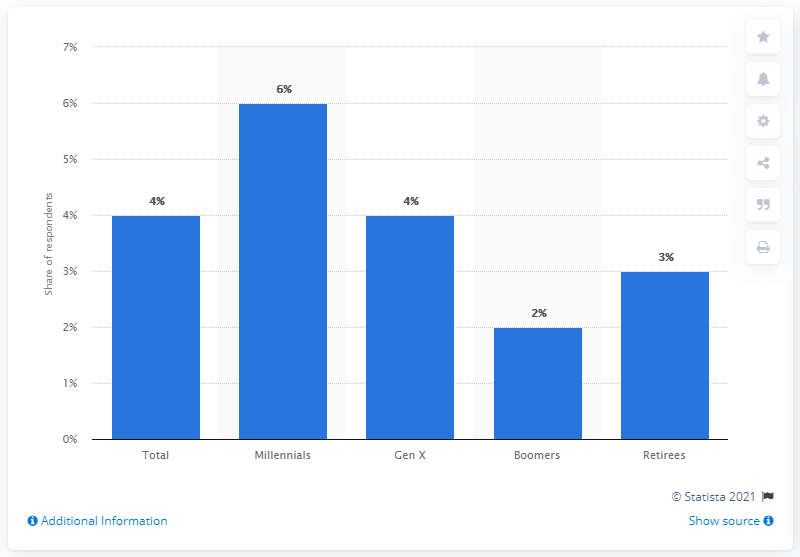Outline some significant characteristics in this image. According to data from February 2017, the age group with the highest share of active FandangoNOW subscriptions in the United States is retirees, making up 3% of the total subscription base. According to recent data, the ratio of Millennials and Baby Boomers in the age group is approximately 3 to 1. 